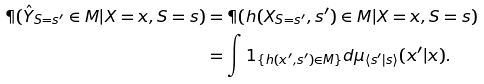Convert formula to latex. <formula><loc_0><loc_0><loc_500><loc_500>\P ( \hat { Y } _ { S = s ^ { \prime } } \in M | X = x , S = s ) & = \P ( h ( X _ { S = s ^ { \prime } } , s ^ { \prime } ) \in M | X = x , S = s ) \\ & = \int 1 _ { \{ h ( x ^ { \prime } , s ^ { \prime } ) \in M \} } d \mu _ { \langle s ^ { \prime } | s \rangle } ( x ^ { \prime } | x ) .</formula> 